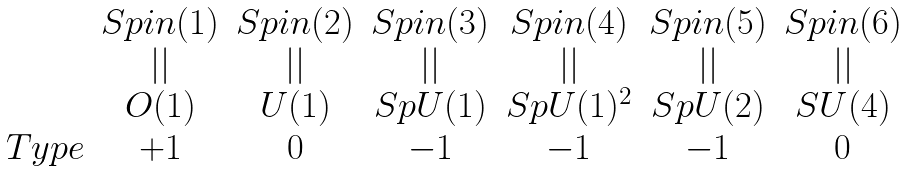Convert formula to latex. <formula><loc_0><loc_0><loc_500><loc_500>\begin{array} { r c c c c c c } & S p i n ( 1 ) & S p i n ( 2 ) & S p i n ( 3 ) & S p i n ( 4 ) & S p i n ( 5 ) & S p i n ( 6 ) \\ & | | & | | & | | & | | & | | & | | \\ & O ( 1 ) & U ( 1 ) & S p U ( 1 ) & S p U ( 1 ) ^ { 2 } & S p U ( 2 ) & S U ( 4 ) \\ T y p e & + 1 & 0 & - 1 & - 1 & - 1 & 0 \end{array}</formula> 